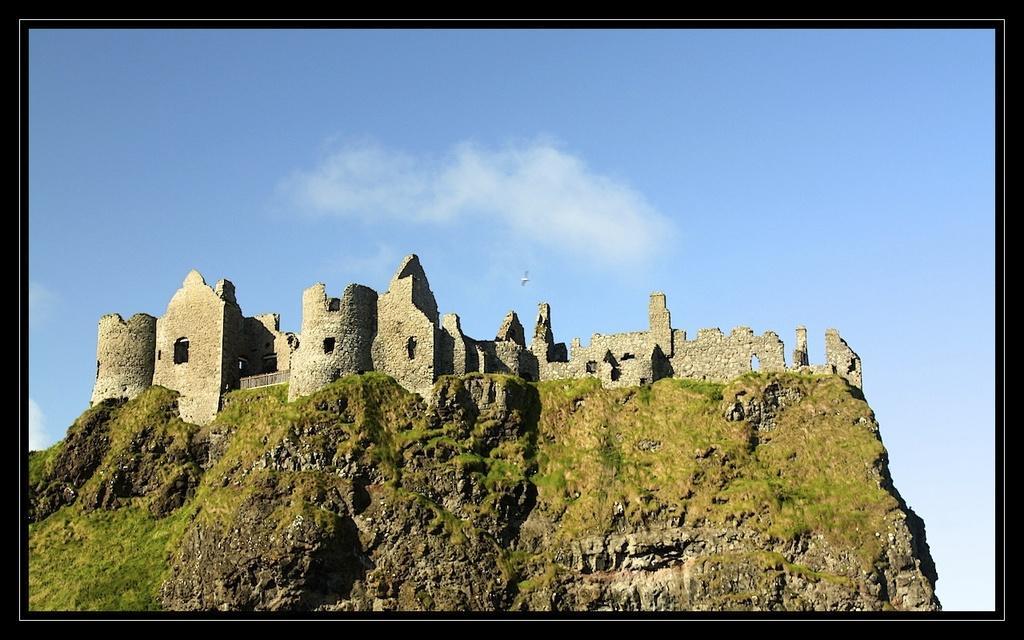Can you describe this image briefly? In the background we can see a clear blue sky. Here we can see a castle. It seems like a bird in the air. 